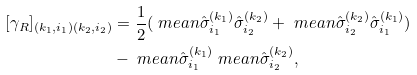Convert formula to latex. <formula><loc_0><loc_0><loc_500><loc_500>[ \gamma _ { R } ] _ { ( k _ { 1 } , i _ { 1 } ) ( k _ { 2 } , i _ { 2 } ) } & = \frac { 1 } { 2 } ( \ m e a n { \hat { \sigma } ^ { ( k _ { 1 } ) } _ { i _ { 1 } } \hat { \sigma } ^ { ( k _ { 2 } ) } _ { i _ { 2 } } } + \ m e a n { \hat { \sigma } ^ { ( k _ { 2 } ) } _ { i _ { 2 } } \hat { \sigma } ^ { ( k _ { 1 } ) } _ { i _ { 1 } } } ) \\ & - \ m e a n { \hat { \sigma } ^ { ( k _ { 1 } ) } _ { i _ { 1 } } } \ m e a n { \hat { \sigma } ^ { ( k _ { 2 } ) } _ { i _ { 2 } } } ,</formula> 